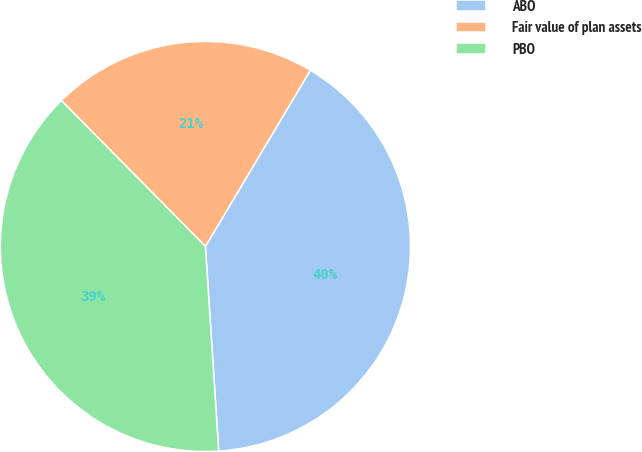<chart> <loc_0><loc_0><loc_500><loc_500><pie_chart><fcel>ABO<fcel>Fair value of plan assets<fcel>PBO<nl><fcel>40.42%<fcel>20.95%<fcel>38.63%<nl></chart> 